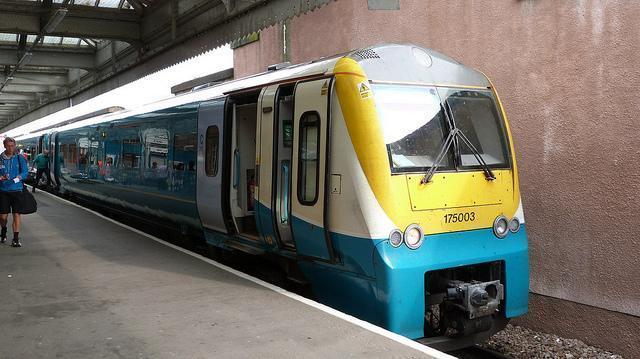How many headlights are on the front of the train?
Give a very brief answer. 4. 